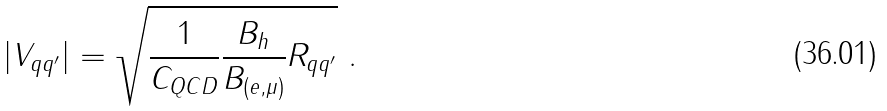<formula> <loc_0><loc_0><loc_500><loc_500>| V _ { q q ^ { \prime } } | = \sqrt { \frac { 1 } { C _ { Q C D } } \frac { B _ { h } } { B _ { ( e , \mu ) } } R _ { q q ^ { \prime } } } \ .</formula> 